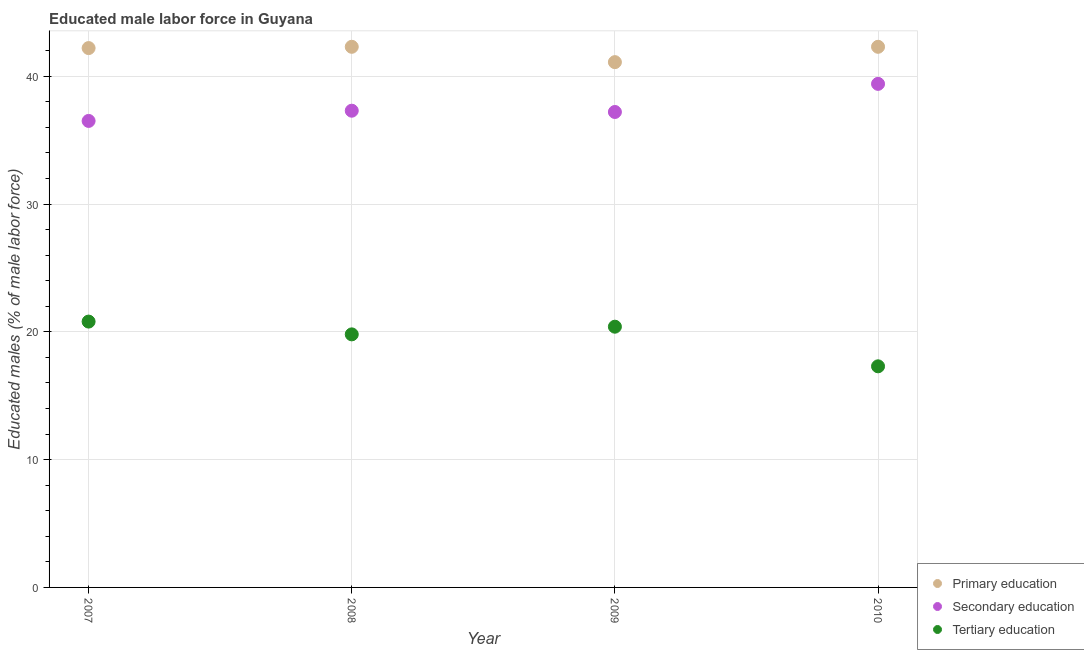Is the number of dotlines equal to the number of legend labels?
Your response must be concise. Yes. What is the percentage of male labor force who received secondary education in 2007?
Offer a very short reply. 36.5. Across all years, what is the maximum percentage of male labor force who received secondary education?
Make the answer very short. 39.4. Across all years, what is the minimum percentage of male labor force who received tertiary education?
Offer a very short reply. 17.3. What is the total percentage of male labor force who received primary education in the graph?
Give a very brief answer. 167.9. What is the difference between the percentage of male labor force who received secondary education in 2010 and the percentage of male labor force who received tertiary education in 2009?
Provide a short and direct response. 19. What is the average percentage of male labor force who received primary education per year?
Provide a succinct answer. 41.97. In the year 2009, what is the difference between the percentage of male labor force who received primary education and percentage of male labor force who received secondary education?
Offer a terse response. 3.9. Is the percentage of male labor force who received primary education in 2007 less than that in 2008?
Ensure brevity in your answer.  Yes. What is the difference between the highest and the second highest percentage of male labor force who received tertiary education?
Provide a succinct answer. 0.4. What is the difference between the highest and the lowest percentage of male labor force who received secondary education?
Provide a short and direct response. 2.9. In how many years, is the percentage of male labor force who received secondary education greater than the average percentage of male labor force who received secondary education taken over all years?
Ensure brevity in your answer.  1. Does the percentage of male labor force who received tertiary education monotonically increase over the years?
Keep it short and to the point. No. Is the percentage of male labor force who received primary education strictly less than the percentage of male labor force who received tertiary education over the years?
Offer a terse response. No. How many years are there in the graph?
Provide a short and direct response. 4. What is the difference between two consecutive major ticks on the Y-axis?
Your response must be concise. 10. Does the graph contain any zero values?
Keep it short and to the point. No. Where does the legend appear in the graph?
Your response must be concise. Bottom right. What is the title of the graph?
Ensure brevity in your answer.  Educated male labor force in Guyana. What is the label or title of the X-axis?
Make the answer very short. Year. What is the label or title of the Y-axis?
Your response must be concise. Educated males (% of male labor force). What is the Educated males (% of male labor force) in Primary education in 2007?
Offer a very short reply. 42.2. What is the Educated males (% of male labor force) in Secondary education in 2007?
Ensure brevity in your answer.  36.5. What is the Educated males (% of male labor force) in Tertiary education in 2007?
Your response must be concise. 20.8. What is the Educated males (% of male labor force) of Primary education in 2008?
Your answer should be very brief. 42.3. What is the Educated males (% of male labor force) in Secondary education in 2008?
Provide a short and direct response. 37.3. What is the Educated males (% of male labor force) in Tertiary education in 2008?
Provide a succinct answer. 19.8. What is the Educated males (% of male labor force) in Primary education in 2009?
Give a very brief answer. 41.1. What is the Educated males (% of male labor force) in Secondary education in 2009?
Offer a very short reply. 37.2. What is the Educated males (% of male labor force) of Tertiary education in 2009?
Offer a terse response. 20.4. What is the Educated males (% of male labor force) in Primary education in 2010?
Provide a short and direct response. 42.3. What is the Educated males (% of male labor force) in Secondary education in 2010?
Your answer should be compact. 39.4. What is the Educated males (% of male labor force) of Tertiary education in 2010?
Offer a terse response. 17.3. Across all years, what is the maximum Educated males (% of male labor force) in Primary education?
Provide a short and direct response. 42.3. Across all years, what is the maximum Educated males (% of male labor force) of Secondary education?
Give a very brief answer. 39.4. Across all years, what is the maximum Educated males (% of male labor force) in Tertiary education?
Keep it short and to the point. 20.8. Across all years, what is the minimum Educated males (% of male labor force) of Primary education?
Make the answer very short. 41.1. Across all years, what is the minimum Educated males (% of male labor force) of Secondary education?
Provide a short and direct response. 36.5. Across all years, what is the minimum Educated males (% of male labor force) in Tertiary education?
Give a very brief answer. 17.3. What is the total Educated males (% of male labor force) of Primary education in the graph?
Your answer should be very brief. 167.9. What is the total Educated males (% of male labor force) in Secondary education in the graph?
Make the answer very short. 150.4. What is the total Educated males (% of male labor force) in Tertiary education in the graph?
Offer a terse response. 78.3. What is the difference between the Educated males (% of male labor force) in Secondary education in 2007 and that in 2008?
Make the answer very short. -0.8. What is the difference between the Educated males (% of male labor force) of Secondary education in 2007 and that in 2009?
Offer a terse response. -0.7. What is the difference between the Educated males (% of male labor force) in Tertiary education in 2007 and that in 2009?
Ensure brevity in your answer.  0.4. What is the difference between the Educated males (% of male labor force) in Primary education in 2007 and that in 2010?
Give a very brief answer. -0.1. What is the difference between the Educated males (% of male labor force) in Secondary education in 2007 and that in 2010?
Give a very brief answer. -2.9. What is the difference between the Educated males (% of male labor force) in Tertiary education in 2008 and that in 2009?
Your answer should be compact. -0.6. What is the difference between the Educated males (% of male labor force) in Secondary education in 2008 and that in 2010?
Your answer should be very brief. -2.1. What is the difference between the Educated males (% of male labor force) in Primary education in 2009 and that in 2010?
Provide a succinct answer. -1.2. What is the difference between the Educated males (% of male labor force) in Secondary education in 2009 and that in 2010?
Ensure brevity in your answer.  -2.2. What is the difference between the Educated males (% of male labor force) in Primary education in 2007 and the Educated males (% of male labor force) in Secondary education in 2008?
Provide a short and direct response. 4.9. What is the difference between the Educated males (% of male labor force) of Primary education in 2007 and the Educated males (% of male labor force) of Tertiary education in 2008?
Give a very brief answer. 22.4. What is the difference between the Educated males (% of male labor force) of Primary education in 2007 and the Educated males (% of male labor force) of Secondary education in 2009?
Make the answer very short. 5. What is the difference between the Educated males (% of male labor force) in Primary education in 2007 and the Educated males (% of male labor force) in Tertiary education in 2009?
Offer a very short reply. 21.8. What is the difference between the Educated males (% of male labor force) in Primary education in 2007 and the Educated males (% of male labor force) in Tertiary education in 2010?
Make the answer very short. 24.9. What is the difference between the Educated males (% of male labor force) of Primary education in 2008 and the Educated males (% of male labor force) of Tertiary education in 2009?
Your answer should be compact. 21.9. What is the difference between the Educated males (% of male labor force) in Secondary education in 2008 and the Educated males (% of male labor force) in Tertiary education in 2009?
Offer a very short reply. 16.9. What is the difference between the Educated males (% of male labor force) in Primary education in 2008 and the Educated males (% of male labor force) in Tertiary education in 2010?
Offer a terse response. 25. What is the difference between the Educated males (% of male labor force) of Secondary education in 2008 and the Educated males (% of male labor force) of Tertiary education in 2010?
Provide a short and direct response. 20. What is the difference between the Educated males (% of male labor force) in Primary education in 2009 and the Educated males (% of male labor force) in Tertiary education in 2010?
Offer a terse response. 23.8. What is the difference between the Educated males (% of male labor force) of Secondary education in 2009 and the Educated males (% of male labor force) of Tertiary education in 2010?
Make the answer very short. 19.9. What is the average Educated males (% of male labor force) in Primary education per year?
Your answer should be very brief. 41.98. What is the average Educated males (% of male labor force) of Secondary education per year?
Offer a very short reply. 37.6. What is the average Educated males (% of male labor force) in Tertiary education per year?
Your answer should be compact. 19.57. In the year 2007, what is the difference between the Educated males (% of male labor force) of Primary education and Educated males (% of male labor force) of Tertiary education?
Make the answer very short. 21.4. In the year 2007, what is the difference between the Educated males (% of male labor force) in Secondary education and Educated males (% of male labor force) in Tertiary education?
Your answer should be compact. 15.7. In the year 2008, what is the difference between the Educated males (% of male labor force) of Primary education and Educated males (% of male labor force) of Tertiary education?
Provide a short and direct response. 22.5. In the year 2008, what is the difference between the Educated males (% of male labor force) in Secondary education and Educated males (% of male labor force) in Tertiary education?
Give a very brief answer. 17.5. In the year 2009, what is the difference between the Educated males (% of male labor force) of Primary education and Educated males (% of male labor force) of Tertiary education?
Keep it short and to the point. 20.7. In the year 2009, what is the difference between the Educated males (% of male labor force) of Secondary education and Educated males (% of male labor force) of Tertiary education?
Your response must be concise. 16.8. In the year 2010, what is the difference between the Educated males (% of male labor force) of Primary education and Educated males (% of male labor force) of Tertiary education?
Provide a succinct answer. 25. In the year 2010, what is the difference between the Educated males (% of male labor force) of Secondary education and Educated males (% of male labor force) of Tertiary education?
Your response must be concise. 22.1. What is the ratio of the Educated males (% of male labor force) of Secondary education in 2007 to that in 2008?
Ensure brevity in your answer.  0.98. What is the ratio of the Educated males (% of male labor force) of Tertiary education in 2007 to that in 2008?
Provide a short and direct response. 1.05. What is the ratio of the Educated males (% of male labor force) of Primary education in 2007 to that in 2009?
Your answer should be compact. 1.03. What is the ratio of the Educated males (% of male labor force) in Secondary education in 2007 to that in 2009?
Offer a very short reply. 0.98. What is the ratio of the Educated males (% of male labor force) in Tertiary education in 2007 to that in 2009?
Offer a terse response. 1.02. What is the ratio of the Educated males (% of male labor force) of Primary education in 2007 to that in 2010?
Your answer should be very brief. 1. What is the ratio of the Educated males (% of male labor force) of Secondary education in 2007 to that in 2010?
Offer a very short reply. 0.93. What is the ratio of the Educated males (% of male labor force) of Tertiary education in 2007 to that in 2010?
Offer a terse response. 1.2. What is the ratio of the Educated males (% of male labor force) of Primary education in 2008 to that in 2009?
Keep it short and to the point. 1.03. What is the ratio of the Educated males (% of male labor force) in Secondary education in 2008 to that in 2009?
Offer a terse response. 1. What is the ratio of the Educated males (% of male labor force) of Tertiary education in 2008 to that in 2009?
Provide a succinct answer. 0.97. What is the ratio of the Educated males (% of male labor force) in Secondary education in 2008 to that in 2010?
Provide a succinct answer. 0.95. What is the ratio of the Educated males (% of male labor force) of Tertiary education in 2008 to that in 2010?
Make the answer very short. 1.14. What is the ratio of the Educated males (% of male labor force) of Primary education in 2009 to that in 2010?
Offer a very short reply. 0.97. What is the ratio of the Educated males (% of male labor force) of Secondary education in 2009 to that in 2010?
Your answer should be very brief. 0.94. What is the ratio of the Educated males (% of male labor force) in Tertiary education in 2009 to that in 2010?
Give a very brief answer. 1.18. What is the difference between the highest and the second highest Educated males (% of male labor force) in Primary education?
Offer a very short reply. 0. What is the difference between the highest and the second highest Educated males (% of male labor force) of Tertiary education?
Offer a very short reply. 0.4. What is the difference between the highest and the lowest Educated males (% of male labor force) in Primary education?
Keep it short and to the point. 1.2. What is the difference between the highest and the lowest Educated males (% of male labor force) of Secondary education?
Keep it short and to the point. 2.9. What is the difference between the highest and the lowest Educated males (% of male labor force) of Tertiary education?
Your answer should be compact. 3.5. 